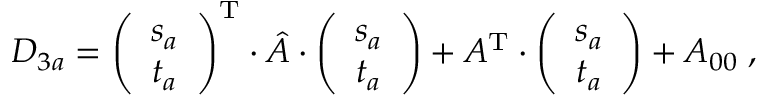<formula> <loc_0><loc_0><loc_500><loc_500>D _ { 3 a } = \left ( \begin{array} { c } { { s _ { a } } } \\ { { t _ { a } } } \end{array} \right ) ^ { T } \cdot \hat { A } \cdot \left ( \begin{array} { c } { { s _ { a } } } \\ { { t _ { a } } } \end{array} \right ) + A ^ { T } \cdot \left ( \begin{array} { c } { { s _ { a } } } \\ { { t _ { a } } } \end{array} \right ) + A _ { 0 0 } \, ,</formula> 